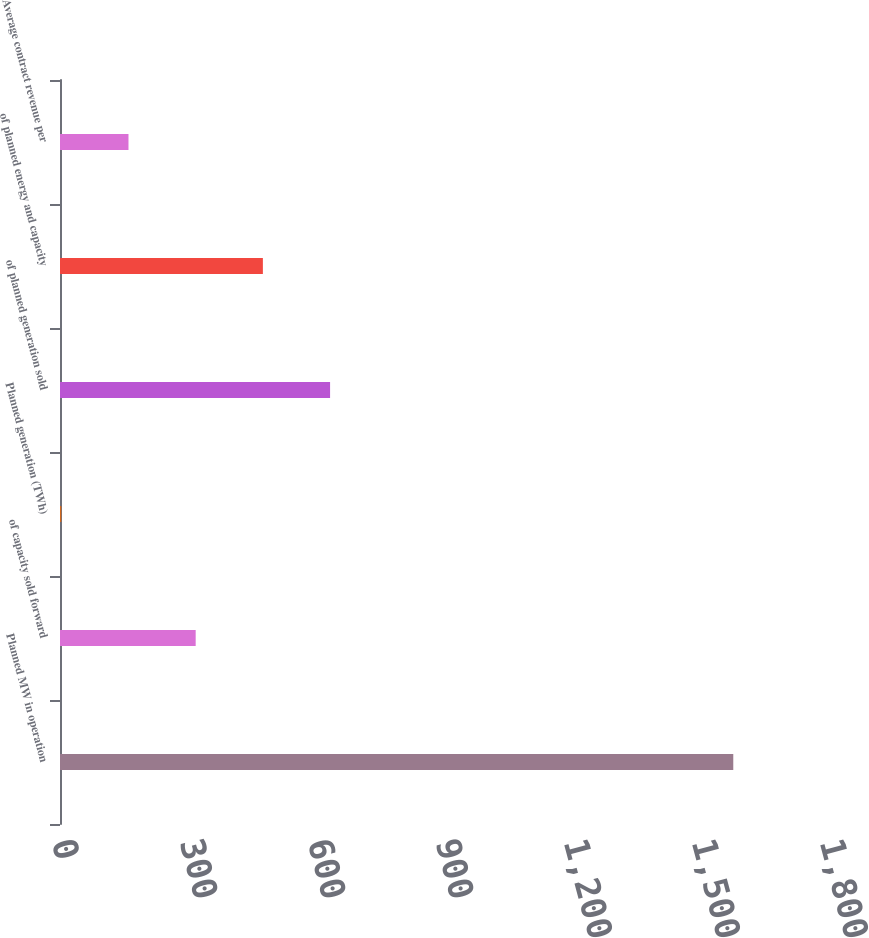Convert chart. <chart><loc_0><loc_0><loc_500><loc_500><bar_chart><fcel>Planned MW in operation<fcel>of capacity sold forward<fcel>Planned generation (TWh)<fcel>of planned generation sold<fcel>of planned energy and capacity<fcel>Average contract revenue per<nl><fcel>1578<fcel>318<fcel>3<fcel>633<fcel>475.5<fcel>160.5<nl></chart> 